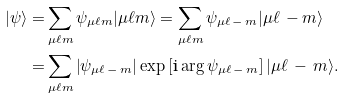<formula> <loc_0><loc_0><loc_500><loc_500>| \psi \rangle = & \sum _ { \mu \ell m } \psi _ { \mu \ell m } | \mu \ell m \rangle = \sum _ { \mu \ell m } \psi _ { \mu \ell \, - \, m } | \mu \ell \, - m \rangle \\ = & \sum _ { \mu \ell m } \left | \psi _ { \mu \ell \, - \, m } \right | \exp \left [ \text {i} \arg \psi _ { \mu \ell \, - \, m } \right ] | \mu \ell \, - \, m \rangle .</formula> 